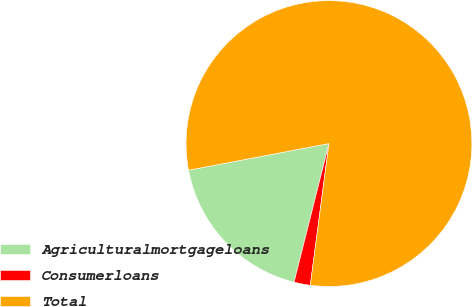Convert chart. <chart><loc_0><loc_0><loc_500><loc_500><pie_chart><fcel>Agriculturalmortgageloans<fcel>Consumerloans<fcel>Total<nl><fcel>18.09%<fcel>1.84%<fcel>80.06%<nl></chart> 